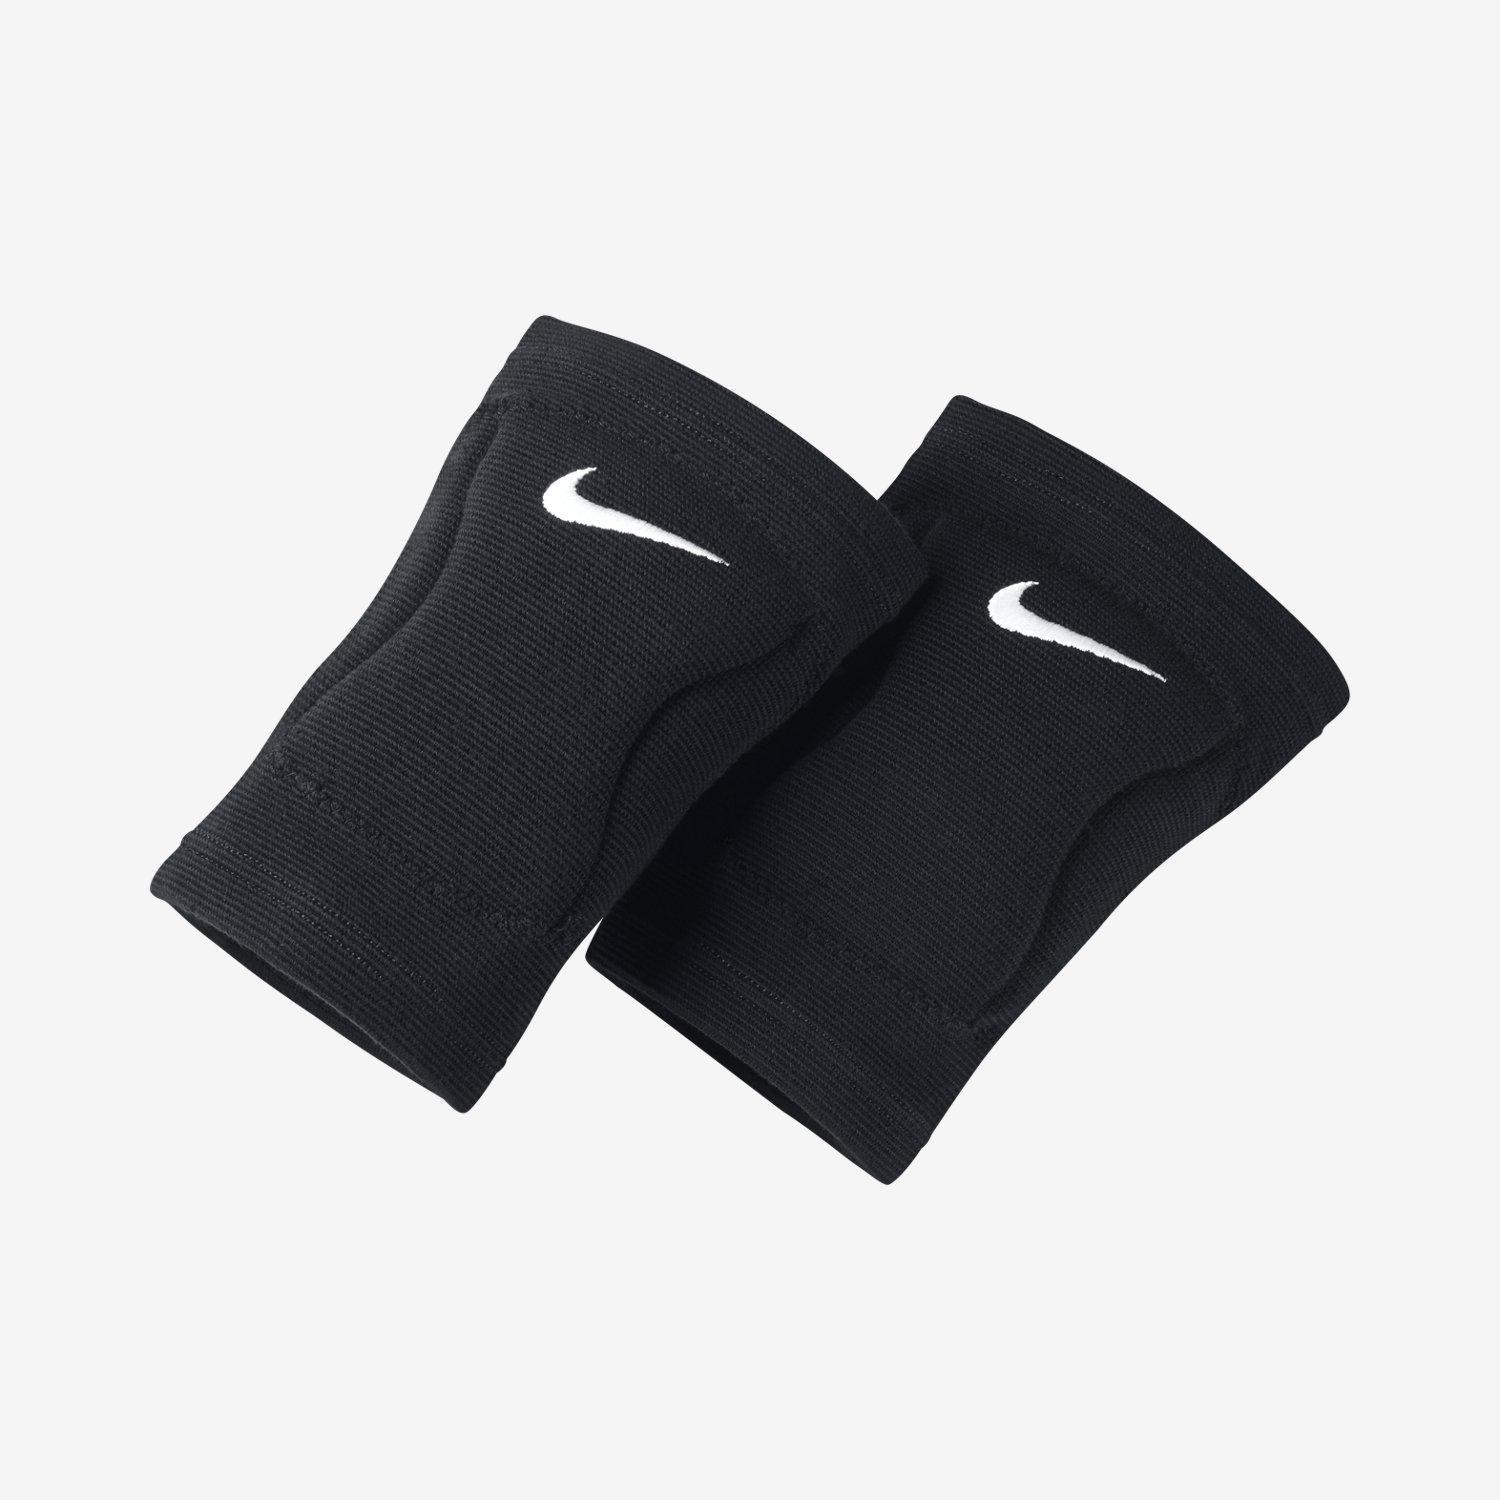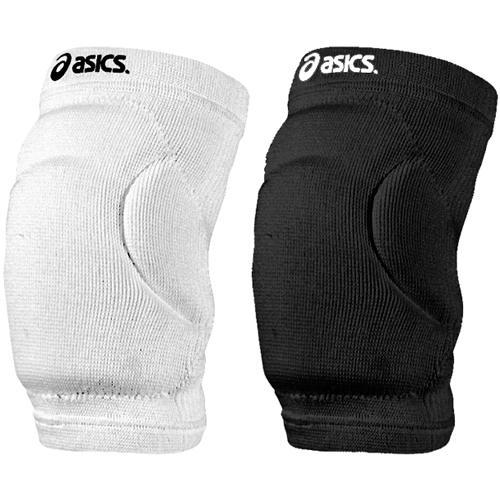The first image is the image on the left, the second image is the image on the right. Evaluate the accuracy of this statement regarding the images: "Three pads are black and one is white.". Is it true? Answer yes or no. Yes. The first image is the image on the left, the second image is the image on the right. Evaluate the accuracy of this statement regarding the images: "The white object is on the right side of the image in the image on the right.". Is it true? Answer yes or no. No. 